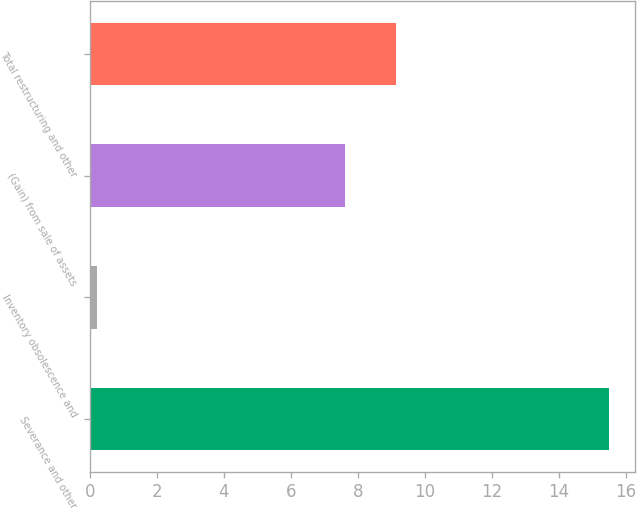<chart> <loc_0><loc_0><loc_500><loc_500><bar_chart><fcel>Severance and other<fcel>Inventory obsolescence and<fcel>(Gain) from sale of assets<fcel>Total restructuring and other<nl><fcel>15.5<fcel>0.2<fcel>7.6<fcel>9.13<nl></chart> 